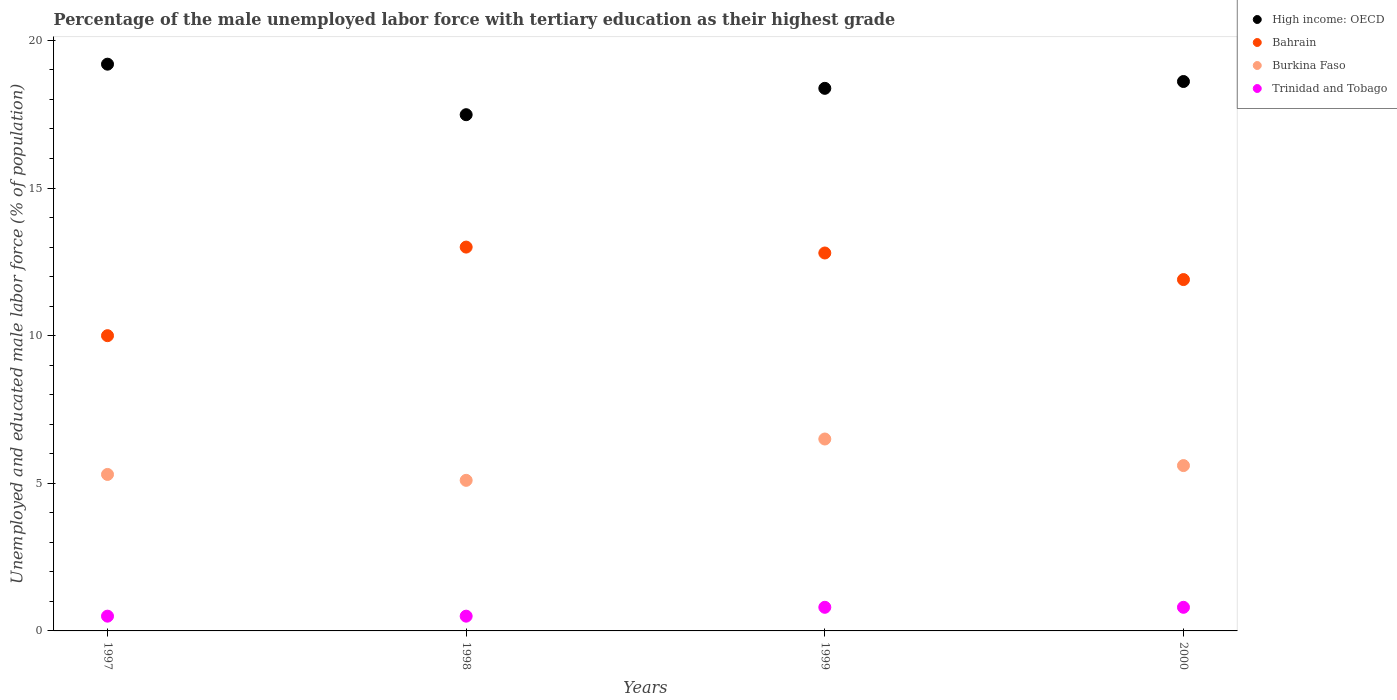How many different coloured dotlines are there?
Offer a terse response. 4. What is the percentage of the unemployed male labor force with tertiary education in Trinidad and Tobago in 1998?
Provide a short and direct response. 0.5. Across all years, what is the maximum percentage of the unemployed male labor force with tertiary education in High income: OECD?
Give a very brief answer. 19.2. Across all years, what is the minimum percentage of the unemployed male labor force with tertiary education in Burkina Faso?
Offer a very short reply. 5.1. What is the total percentage of the unemployed male labor force with tertiary education in Bahrain in the graph?
Provide a short and direct response. 47.7. What is the difference between the percentage of the unemployed male labor force with tertiary education in Trinidad and Tobago in 1999 and that in 2000?
Your response must be concise. 0. What is the difference between the percentage of the unemployed male labor force with tertiary education in Bahrain in 1998 and the percentage of the unemployed male labor force with tertiary education in Trinidad and Tobago in 1999?
Your response must be concise. 12.2. What is the average percentage of the unemployed male labor force with tertiary education in Trinidad and Tobago per year?
Provide a succinct answer. 0.65. In the year 1998, what is the difference between the percentage of the unemployed male labor force with tertiary education in Trinidad and Tobago and percentage of the unemployed male labor force with tertiary education in Bahrain?
Offer a terse response. -12.5. In how many years, is the percentage of the unemployed male labor force with tertiary education in Bahrain greater than 16 %?
Make the answer very short. 0. What is the ratio of the percentage of the unemployed male labor force with tertiary education in Burkina Faso in 1998 to that in 2000?
Offer a terse response. 0.91. Is the percentage of the unemployed male labor force with tertiary education in High income: OECD in 1997 less than that in 2000?
Your answer should be very brief. No. What is the difference between the highest and the second highest percentage of the unemployed male labor force with tertiary education in High income: OECD?
Keep it short and to the point. 0.59. What is the difference between the highest and the lowest percentage of the unemployed male labor force with tertiary education in Bahrain?
Your response must be concise. 3. In how many years, is the percentage of the unemployed male labor force with tertiary education in Burkina Faso greater than the average percentage of the unemployed male labor force with tertiary education in Burkina Faso taken over all years?
Make the answer very short. 1. Is it the case that in every year, the sum of the percentage of the unemployed male labor force with tertiary education in Trinidad and Tobago and percentage of the unemployed male labor force with tertiary education in High income: OECD  is greater than the sum of percentage of the unemployed male labor force with tertiary education in Bahrain and percentage of the unemployed male labor force with tertiary education in Burkina Faso?
Provide a short and direct response. No. Is it the case that in every year, the sum of the percentage of the unemployed male labor force with tertiary education in Trinidad and Tobago and percentage of the unemployed male labor force with tertiary education in High income: OECD  is greater than the percentage of the unemployed male labor force with tertiary education in Bahrain?
Offer a very short reply. Yes. Does the graph contain grids?
Offer a very short reply. No. How many legend labels are there?
Ensure brevity in your answer.  4. What is the title of the graph?
Keep it short and to the point. Percentage of the male unemployed labor force with tertiary education as their highest grade. What is the label or title of the X-axis?
Keep it short and to the point. Years. What is the label or title of the Y-axis?
Make the answer very short. Unemployed and educated male labor force (% of population). What is the Unemployed and educated male labor force (% of population) in High income: OECD in 1997?
Your response must be concise. 19.2. What is the Unemployed and educated male labor force (% of population) in Bahrain in 1997?
Your answer should be very brief. 10. What is the Unemployed and educated male labor force (% of population) of Burkina Faso in 1997?
Offer a terse response. 5.3. What is the Unemployed and educated male labor force (% of population) of High income: OECD in 1998?
Offer a very short reply. 17.48. What is the Unemployed and educated male labor force (% of population) of Bahrain in 1998?
Provide a short and direct response. 13. What is the Unemployed and educated male labor force (% of population) in Burkina Faso in 1998?
Provide a short and direct response. 5.1. What is the Unemployed and educated male labor force (% of population) of High income: OECD in 1999?
Your answer should be very brief. 18.38. What is the Unemployed and educated male labor force (% of population) in Bahrain in 1999?
Give a very brief answer. 12.8. What is the Unemployed and educated male labor force (% of population) of Burkina Faso in 1999?
Ensure brevity in your answer.  6.5. What is the Unemployed and educated male labor force (% of population) of Trinidad and Tobago in 1999?
Ensure brevity in your answer.  0.8. What is the Unemployed and educated male labor force (% of population) in High income: OECD in 2000?
Your answer should be very brief. 18.61. What is the Unemployed and educated male labor force (% of population) of Bahrain in 2000?
Keep it short and to the point. 11.9. What is the Unemployed and educated male labor force (% of population) in Burkina Faso in 2000?
Give a very brief answer. 5.6. What is the Unemployed and educated male labor force (% of population) of Trinidad and Tobago in 2000?
Provide a short and direct response. 0.8. Across all years, what is the maximum Unemployed and educated male labor force (% of population) of High income: OECD?
Provide a short and direct response. 19.2. Across all years, what is the maximum Unemployed and educated male labor force (% of population) in Burkina Faso?
Give a very brief answer. 6.5. Across all years, what is the maximum Unemployed and educated male labor force (% of population) in Trinidad and Tobago?
Ensure brevity in your answer.  0.8. Across all years, what is the minimum Unemployed and educated male labor force (% of population) of High income: OECD?
Your response must be concise. 17.48. Across all years, what is the minimum Unemployed and educated male labor force (% of population) in Bahrain?
Give a very brief answer. 10. Across all years, what is the minimum Unemployed and educated male labor force (% of population) of Burkina Faso?
Offer a terse response. 5.1. What is the total Unemployed and educated male labor force (% of population) of High income: OECD in the graph?
Provide a short and direct response. 73.67. What is the total Unemployed and educated male labor force (% of population) in Bahrain in the graph?
Make the answer very short. 47.7. What is the total Unemployed and educated male labor force (% of population) of Trinidad and Tobago in the graph?
Provide a short and direct response. 2.6. What is the difference between the Unemployed and educated male labor force (% of population) of High income: OECD in 1997 and that in 1998?
Provide a short and direct response. 1.71. What is the difference between the Unemployed and educated male labor force (% of population) of Bahrain in 1997 and that in 1998?
Make the answer very short. -3. What is the difference between the Unemployed and educated male labor force (% of population) in Trinidad and Tobago in 1997 and that in 1998?
Ensure brevity in your answer.  0. What is the difference between the Unemployed and educated male labor force (% of population) of High income: OECD in 1997 and that in 1999?
Offer a very short reply. 0.82. What is the difference between the Unemployed and educated male labor force (% of population) of Trinidad and Tobago in 1997 and that in 1999?
Give a very brief answer. -0.3. What is the difference between the Unemployed and educated male labor force (% of population) in High income: OECD in 1997 and that in 2000?
Keep it short and to the point. 0.59. What is the difference between the Unemployed and educated male labor force (% of population) of High income: OECD in 1998 and that in 1999?
Your answer should be very brief. -0.89. What is the difference between the Unemployed and educated male labor force (% of population) in Bahrain in 1998 and that in 1999?
Provide a succinct answer. 0.2. What is the difference between the Unemployed and educated male labor force (% of population) in Burkina Faso in 1998 and that in 1999?
Your answer should be very brief. -1.4. What is the difference between the Unemployed and educated male labor force (% of population) of Trinidad and Tobago in 1998 and that in 1999?
Your answer should be compact. -0.3. What is the difference between the Unemployed and educated male labor force (% of population) of High income: OECD in 1998 and that in 2000?
Offer a very short reply. -1.12. What is the difference between the Unemployed and educated male labor force (% of population) of Bahrain in 1998 and that in 2000?
Provide a short and direct response. 1.1. What is the difference between the Unemployed and educated male labor force (% of population) of Burkina Faso in 1998 and that in 2000?
Keep it short and to the point. -0.5. What is the difference between the Unemployed and educated male labor force (% of population) in High income: OECD in 1999 and that in 2000?
Provide a succinct answer. -0.23. What is the difference between the Unemployed and educated male labor force (% of population) of Bahrain in 1999 and that in 2000?
Provide a short and direct response. 0.9. What is the difference between the Unemployed and educated male labor force (% of population) in High income: OECD in 1997 and the Unemployed and educated male labor force (% of population) in Bahrain in 1998?
Your answer should be very brief. 6.2. What is the difference between the Unemployed and educated male labor force (% of population) of High income: OECD in 1997 and the Unemployed and educated male labor force (% of population) of Burkina Faso in 1998?
Give a very brief answer. 14.1. What is the difference between the Unemployed and educated male labor force (% of population) of High income: OECD in 1997 and the Unemployed and educated male labor force (% of population) of Trinidad and Tobago in 1998?
Offer a very short reply. 18.7. What is the difference between the Unemployed and educated male labor force (% of population) of Burkina Faso in 1997 and the Unemployed and educated male labor force (% of population) of Trinidad and Tobago in 1998?
Provide a short and direct response. 4.8. What is the difference between the Unemployed and educated male labor force (% of population) in High income: OECD in 1997 and the Unemployed and educated male labor force (% of population) in Bahrain in 1999?
Your response must be concise. 6.4. What is the difference between the Unemployed and educated male labor force (% of population) of High income: OECD in 1997 and the Unemployed and educated male labor force (% of population) of Burkina Faso in 1999?
Provide a short and direct response. 12.7. What is the difference between the Unemployed and educated male labor force (% of population) in High income: OECD in 1997 and the Unemployed and educated male labor force (% of population) in Trinidad and Tobago in 1999?
Provide a short and direct response. 18.4. What is the difference between the Unemployed and educated male labor force (% of population) in Bahrain in 1997 and the Unemployed and educated male labor force (% of population) in Trinidad and Tobago in 1999?
Offer a very short reply. 9.2. What is the difference between the Unemployed and educated male labor force (% of population) in High income: OECD in 1997 and the Unemployed and educated male labor force (% of population) in Bahrain in 2000?
Offer a terse response. 7.3. What is the difference between the Unemployed and educated male labor force (% of population) in High income: OECD in 1997 and the Unemployed and educated male labor force (% of population) in Burkina Faso in 2000?
Offer a very short reply. 13.6. What is the difference between the Unemployed and educated male labor force (% of population) of High income: OECD in 1997 and the Unemployed and educated male labor force (% of population) of Trinidad and Tobago in 2000?
Your answer should be compact. 18.4. What is the difference between the Unemployed and educated male labor force (% of population) in Bahrain in 1997 and the Unemployed and educated male labor force (% of population) in Burkina Faso in 2000?
Your answer should be very brief. 4.4. What is the difference between the Unemployed and educated male labor force (% of population) of Burkina Faso in 1997 and the Unemployed and educated male labor force (% of population) of Trinidad and Tobago in 2000?
Your answer should be very brief. 4.5. What is the difference between the Unemployed and educated male labor force (% of population) in High income: OECD in 1998 and the Unemployed and educated male labor force (% of population) in Bahrain in 1999?
Provide a short and direct response. 4.68. What is the difference between the Unemployed and educated male labor force (% of population) of High income: OECD in 1998 and the Unemployed and educated male labor force (% of population) of Burkina Faso in 1999?
Provide a short and direct response. 10.98. What is the difference between the Unemployed and educated male labor force (% of population) in High income: OECD in 1998 and the Unemployed and educated male labor force (% of population) in Trinidad and Tobago in 1999?
Make the answer very short. 16.68. What is the difference between the Unemployed and educated male labor force (% of population) of High income: OECD in 1998 and the Unemployed and educated male labor force (% of population) of Bahrain in 2000?
Provide a short and direct response. 5.58. What is the difference between the Unemployed and educated male labor force (% of population) in High income: OECD in 1998 and the Unemployed and educated male labor force (% of population) in Burkina Faso in 2000?
Provide a succinct answer. 11.88. What is the difference between the Unemployed and educated male labor force (% of population) in High income: OECD in 1998 and the Unemployed and educated male labor force (% of population) in Trinidad and Tobago in 2000?
Ensure brevity in your answer.  16.68. What is the difference between the Unemployed and educated male labor force (% of population) in Bahrain in 1998 and the Unemployed and educated male labor force (% of population) in Burkina Faso in 2000?
Your response must be concise. 7.4. What is the difference between the Unemployed and educated male labor force (% of population) in Bahrain in 1998 and the Unemployed and educated male labor force (% of population) in Trinidad and Tobago in 2000?
Offer a terse response. 12.2. What is the difference between the Unemployed and educated male labor force (% of population) in Burkina Faso in 1998 and the Unemployed and educated male labor force (% of population) in Trinidad and Tobago in 2000?
Provide a short and direct response. 4.3. What is the difference between the Unemployed and educated male labor force (% of population) in High income: OECD in 1999 and the Unemployed and educated male labor force (% of population) in Bahrain in 2000?
Offer a very short reply. 6.48. What is the difference between the Unemployed and educated male labor force (% of population) of High income: OECD in 1999 and the Unemployed and educated male labor force (% of population) of Burkina Faso in 2000?
Your answer should be very brief. 12.78. What is the difference between the Unemployed and educated male labor force (% of population) in High income: OECD in 1999 and the Unemployed and educated male labor force (% of population) in Trinidad and Tobago in 2000?
Ensure brevity in your answer.  17.58. What is the difference between the Unemployed and educated male labor force (% of population) in Bahrain in 1999 and the Unemployed and educated male labor force (% of population) in Trinidad and Tobago in 2000?
Offer a very short reply. 12. What is the difference between the Unemployed and educated male labor force (% of population) in Burkina Faso in 1999 and the Unemployed and educated male labor force (% of population) in Trinidad and Tobago in 2000?
Your answer should be very brief. 5.7. What is the average Unemployed and educated male labor force (% of population) of High income: OECD per year?
Offer a very short reply. 18.42. What is the average Unemployed and educated male labor force (% of population) of Bahrain per year?
Provide a short and direct response. 11.93. What is the average Unemployed and educated male labor force (% of population) in Burkina Faso per year?
Give a very brief answer. 5.62. What is the average Unemployed and educated male labor force (% of population) of Trinidad and Tobago per year?
Ensure brevity in your answer.  0.65. In the year 1997, what is the difference between the Unemployed and educated male labor force (% of population) in High income: OECD and Unemployed and educated male labor force (% of population) in Bahrain?
Ensure brevity in your answer.  9.2. In the year 1997, what is the difference between the Unemployed and educated male labor force (% of population) in High income: OECD and Unemployed and educated male labor force (% of population) in Burkina Faso?
Your answer should be compact. 13.9. In the year 1997, what is the difference between the Unemployed and educated male labor force (% of population) in High income: OECD and Unemployed and educated male labor force (% of population) in Trinidad and Tobago?
Make the answer very short. 18.7. In the year 1997, what is the difference between the Unemployed and educated male labor force (% of population) in Bahrain and Unemployed and educated male labor force (% of population) in Burkina Faso?
Provide a short and direct response. 4.7. In the year 1997, what is the difference between the Unemployed and educated male labor force (% of population) of Burkina Faso and Unemployed and educated male labor force (% of population) of Trinidad and Tobago?
Your response must be concise. 4.8. In the year 1998, what is the difference between the Unemployed and educated male labor force (% of population) in High income: OECD and Unemployed and educated male labor force (% of population) in Bahrain?
Offer a very short reply. 4.48. In the year 1998, what is the difference between the Unemployed and educated male labor force (% of population) in High income: OECD and Unemployed and educated male labor force (% of population) in Burkina Faso?
Make the answer very short. 12.38. In the year 1998, what is the difference between the Unemployed and educated male labor force (% of population) of High income: OECD and Unemployed and educated male labor force (% of population) of Trinidad and Tobago?
Give a very brief answer. 16.98. In the year 1998, what is the difference between the Unemployed and educated male labor force (% of population) in Bahrain and Unemployed and educated male labor force (% of population) in Burkina Faso?
Ensure brevity in your answer.  7.9. In the year 1998, what is the difference between the Unemployed and educated male labor force (% of population) in Burkina Faso and Unemployed and educated male labor force (% of population) in Trinidad and Tobago?
Ensure brevity in your answer.  4.6. In the year 1999, what is the difference between the Unemployed and educated male labor force (% of population) of High income: OECD and Unemployed and educated male labor force (% of population) of Bahrain?
Provide a succinct answer. 5.58. In the year 1999, what is the difference between the Unemployed and educated male labor force (% of population) of High income: OECD and Unemployed and educated male labor force (% of population) of Burkina Faso?
Ensure brevity in your answer.  11.88. In the year 1999, what is the difference between the Unemployed and educated male labor force (% of population) of High income: OECD and Unemployed and educated male labor force (% of population) of Trinidad and Tobago?
Ensure brevity in your answer.  17.58. In the year 1999, what is the difference between the Unemployed and educated male labor force (% of population) in Bahrain and Unemployed and educated male labor force (% of population) in Burkina Faso?
Offer a terse response. 6.3. In the year 1999, what is the difference between the Unemployed and educated male labor force (% of population) in Bahrain and Unemployed and educated male labor force (% of population) in Trinidad and Tobago?
Ensure brevity in your answer.  12. In the year 1999, what is the difference between the Unemployed and educated male labor force (% of population) of Burkina Faso and Unemployed and educated male labor force (% of population) of Trinidad and Tobago?
Your response must be concise. 5.7. In the year 2000, what is the difference between the Unemployed and educated male labor force (% of population) of High income: OECD and Unemployed and educated male labor force (% of population) of Bahrain?
Offer a terse response. 6.71. In the year 2000, what is the difference between the Unemployed and educated male labor force (% of population) in High income: OECD and Unemployed and educated male labor force (% of population) in Burkina Faso?
Make the answer very short. 13.01. In the year 2000, what is the difference between the Unemployed and educated male labor force (% of population) in High income: OECD and Unemployed and educated male labor force (% of population) in Trinidad and Tobago?
Your answer should be compact. 17.81. In the year 2000, what is the difference between the Unemployed and educated male labor force (% of population) of Bahrain and Unemployed and educated male labor force (% of population) of Burkina Faso?
Your answer should be very brief. 6.3. What is the ratio of the Unemployed and educated male labor force (% of population) of High income: OECD in 1997 to that in 1998?
Provide a succinct answer. 1.1. What is the ratio of the Unemployed and educated male labor force (% of population) in Bahrain in 1997 to that in 1998?
Ensure brevity in your answer.  0.77. What is the ratio of the Unemployed and educated male labor force (% of population) of Burkina Faso in 1997 to that in 1998?
Ensure brevity in your answer.  1.04. What is the ratio of the Unemployed and educated male labor force (% of population) of Trinidad and Tobago in 1997 to that in 1998?
Make the answer very short. 1. What is the ratio of the Unemployed and educated male labor force (% of population) in High income: OECD in 1997 to that in 1999?
Your response must be concise. 1.04. What is the ratio of the Unemployed and educated male labor force (% of population) in Bahrain in 1997 to that in 1999?
Offer a terse response. 0.78. What is the ratio of the Unemployed and educated male labor force (% of population) in Burkina Faso in 1997 to that in 1999?
Your answer should be very brief. 0.82. What is the ratio of the Unemployed and educated male labor force (% of population) of High income: OECD in 1997 to that in 2000?
Your answer should be very brief. 1.03. What is the ratio of the Unemployed and educated male labor force (% of population) in Bahrain in 1997 to that in 2000?
Your answer should be very brief. 0.84. What is the ratio of the Unemployed and educated male labor force (% of population) of Burkina Faso in 1997 to that in 2000?
Offer a very short reply. 0.95. What is the ratio of the Unemployed and educated male labor force (% of population) in High income: OECD in 1998 to that in 1999?
Your answer should be very brief. 0.95. What is the ratio of the Unemployed and educated male labor force (% of population) in Bahrain in 1998 to that in 1999?
Ensure brevity in your answer.  1.02. What is the ratio of the Unemployed and educated male labor force (% of population) of Burkina Faso in 1998 to that in 1999?
Provide a succinct answer. 0.78. What is the ratio of the Unemployed and educated male labor force (% of population) of Trinidad and Tobago in 1998 to that in 1999?
Provide a short and direct response. 0.62. What is the ratio of the Unemployed and educated male labor force (% of population) of High income: OECD in 1998 to that in 2000?
Offer a very short reply. 0.94. What is the ratio of the Unemployed and educated male labor force (% of population) in Bahrain in 1998 to that in 2000?
Make the answer very short. 1.09. What is the ratio of the Unemployed and educated male labor force (% of population) in Burkina Faso in 1998 to that in 2000?
Your answer should be compact. 0.91. What is the ratio of the Unemployed and educated male labor force (% of population) in Trinidad and Tobago in 1998 to that in 2000?
Give a very brief answer. 0.62. What is the ratio of the Unemployed and educated male labor force (% of population) of High income: OECD in 1999 to that in 2000?
Ensure brevity in your answer.  0.99. What is the ratio of the Unemployed and educated male labor force (% of population) of Bahrain in 1999 to that in 2000?
Provide a short and direct response. 1.08. What is the ratio of the Unemployed and educated male labor force (% of population) in Burkina Faso in 1999 to that in 2000?
Your response must be concise. 1.16. What is the difference between the highest and the second highest Unemployed and educated male labor force (% of population) of High income: OECD?
Provide a short and direct response. 0.59. What is the difference between the highest and the second highest Unemployed and educated male labor force (% of population) in Bahrain?
Give a very brief answer. 0.2. What is the difference between the highest and the lowest Unemployed and educated male labor force (% of population) in High income: OECD?
Your answer should be compact. 1.71. 